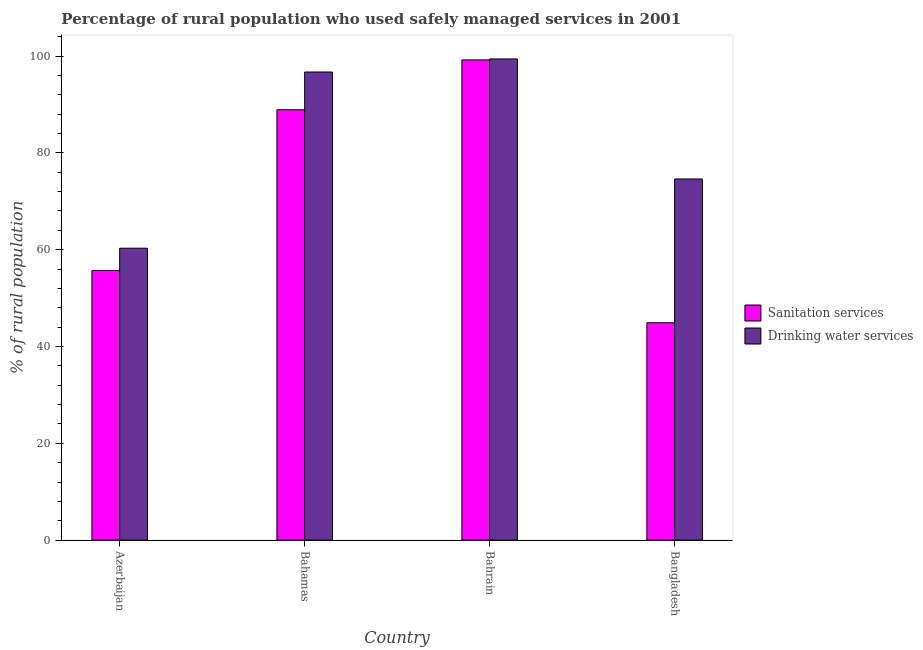How many different coloured bars are there?
Give a very brief answer. 2. How many groups of bars are there?
Provide a succinct answer. 4. How many bars are there on the 4th tick from the right?
Offer a very short reply. 2. What is the label of the 1st group of bars from the left?
Keep it short and to the point. Azerbaijan. In how many cases, is the number of bars for a given country not equal to the number of legend labels?
Keep it short and to the point. 0. What is the percentage of rural population who used drinking water services in Bahrain?
Your response must be concise. 99.4. Across all countries, what is the maximum percentage of rural population who used drinking water services?
Provide a short and direct response. 99.4. Across all countries, what is the minimum percentage of rural population who used sanitation services?
Keep it short and to the point. 44.9. In which country was the percentage of rural population who used drinking water services maximum?
Give a very brief answer. Bahrain. In which country was the percentage of rural population who used drinking water services minimum?
Ensure brevity in your answer.  Azerbaijan. What is the total percentage of rural population who used sanitation services in the graph?
Give a very brief answer. 288.7. What is the difference between the percentage of rural population who used sanitation services in Azerbaijan and that in Bahamas?
Your response must be concise. -33.2. What is the difference between the percentage of rural population who used sanitation services in Bahrain and the percentage of rural population who used drinking water services in Azerbaijan?
Provide a short and direct response. 38.9. What is the average percentage of rural population who used drinking water services per country?
Ensure brevity in your answer.  82.75. What is the difference between the percentage of rural population who used drinking water services and percentage of rural population who used sanitation services in Bahamas?
Keep it short and to the point. 7.8. What is the ratio of the percentage of rural population who used sanitation services in Bahrain to that in Bangladesh?
Make the answer very short. 2.21. Is the percentage of rural population who used drinking water services in Bahrain less than that in Bangladesh?
Offer a very short reply. No. Is the difference between the percentage of rural population who used drinking water services in Bahamas and Bangladesh greater than the difference between the percentage of rural population who used sanitation services in Bahamas and Bangladesh?
Your answer should be very brief. No. What is the difference between the highest and the second highest percentage of rural population who used sanitation services?
Provide a succinct answer. 10.3. What is the difference between the highest and the lowest percentage of rural population who used drinking water services?
Your response must be concise. 39.1. What does the 2nd bar from the left in Bahrain represents?
Give a very brief answer. Drinking water services. What does the 2nd bar from the right in Bangladesh represents?
Offer a very short reply. Sanitation services. What is the difference between two consecutive major ticks on the Y-axis?
Your response must be concise. 20. Does the graph contain grids?
Ensure brevity in your answer.  No. Where does the legend appear in the graph?
Give a very brief answer. Center right. How many legend labels are there?
Your answer should be compact. 2. How are the legend labels stacked?
Give a very brief answer. Vertical. What is the title of the graph?
Your response must be concise. Percentage of rural population who used safely managed services in 2001. What is the label or title of the Y-axis?
Ensure brevity in your answer.  % of rural population. What is the % of rural population in Sanitation services in Azerbaijan?
Offer a very short reply. 55.7. What is the % of rural population in Drinking water services in Azerbaijan?
Ensure brevity in your answer.  60.3. What is the % of rural population in Sanitation services in Bahamas?
Keep it short and to the point. 88.9. What is the % of rural population in Drinking water services in Bahamas?
Your answer should be compact. 96.7. What is the % of rural population in Sanitation services in Bahrain?
Ensure brevity in your answer.  99.2. What is the % of rural population of Drinking water services in Bahrain?
Provide a succinct answer. 99.4. What is the % of rural population of Sanitation services in Bangladesh?
Give a very brief answer. 44.9. What is the % of rural population of Drinking water services in Bangladesh?
Give a very brief answer. 74.6. Across all countries, what is the maximum % of rural population of Sanitation services?
Make the answer very short. 99.2. Across all countries, what is the maximum % of rural population of Drinking water services?
Ensure brevity in your answer.  99.4. Across all countries, what is the minimum % of rural population of Sanitation services?
Your answer should be compact. 44.9. Across all countries, what is the minimum % of rural population of Drinking water services?
Your answer should be very brief. 60.3. What is the total % of rural population of Sanitation services in the graph?
Your answer should be compact. 288.7. What is the total % of rural population of Drinking water services in the graph?
Ensure brevity in your answer.  331. What is the difference between the % of rural population of Sanitation services in Azerbaijan and that in Bahamas?
Keep it short and to the point. -33.2. What is the difference between the % of rural population of Drinking water services in Azerbaijan and that in Bahamas?
Your answer should be compact. -36.4. What is the difference between the % of rural population in Sanitation services in Azerbaijan and that in Bahrain?
Make the answer very short. -43.5. What is the difference between the % of rural population of Drinking water services in Azerbaijan and that in Bahrain?
Your answer should be very brief. -39.1. What is the difference between the % of rural population of Sanitation services in Azerbaijan and that in Bangladesh?
Provide a succinct answer. 10.8. What is the difference between the % of rural population of Drinking water services in Azerbaijan and that in Bangladesh?
Provide a short and direct response. -14.3. What is the difference between the % of rural population in Drinking water services in Bahamas and that in Bangladesh?
Give a very brief answer. 22.1. What is the difference between the % of rural population in Sanitation services in Bahrain and that in Bangladesh?
Give a very brief answer. 54.3. What is the difference between the % of rural population in Drinking water services in Bahrain and that in Bangladesh?
Your response must be concise. 24.8. What is the difference between the % of rural population in Sanitation services in Azerbaijan and the % of rural population in Drinking water services in Bahamas?
Make the answer very short. -41. What is the difference between the % of rural population in Sanitation services in Azerbaijan and the % of rural population in Drinking water services in Bahrain?
Your response must be concise. -43.7. What is the difference between the % of rural population of Sanitation services in Azerbaijan and the % of rural population of Drinking water services in Bangladesh?
Give a very brief answer. -18.9. What is the difference between the % of rural population in Sanitation services in Bahamas and the % of rural population in Drinking water services in Bangladesh?
Your answer should be very brief. 14.3. What is the difference between the % of rural population of Sanitation services in Bahrain and the % of rural population of Drinking water services in Bangladesh?
Offer a very short reply. 24.6. What is the average % of rural population in Sanitation services per country?
Ensure brevity in your answer.  72.17. What is the average % of rural population in Drinking water services per country?
Make the answer very short. 82.75. What is the difference between the % of rural population in Sanitation services and % of rural population in Drinking water services in Azerbaijan?
Keep it short and to the point. -4.6. What is the difference between the % of rural population of Sanitation services and % of rural population of Drinking water services in Bahamas?
Ensure brevity in your answer.  -7.8. What is the difference between the % of rural population of Sanitation services and % of rural population of Drinking water services in Bahrain?
Provide a succinct answer. -0.2. What is the difference between the % of rural population of Sanitation services and % of rural population of Drinking water services in Bangladesh?
Provide a succinct answer. -29.7. What is the ratio of the % of rural population in Sanitation services in Azerbaijan to that in Bahamas?
Your response must be concise. 0.63. What is the ratio of the % of rural population in Drinking water services in Azerbaijan to that in Bahamas?
Make the answer very short. 0.62. What is the ratio of the % of rural population in Sanitation services in Azerbaijan to that in Bahrain?
Your answer should be very brief. 0.56. What is the ratio of the % of rural population in Drinking water services in Azerbaijan to that in Bahrain?
Give a very brief answer. 0.61. What is the ratio of the % of rural population of Sanitation services in Azerbaijan to that in Bangladesh?
Keep it short and to the point. 1.24. What is the ratio of the % of rural population in Drinking water services in Azerbaijan to that in Bangladesh?
Your response must be concise. 0.81. What is the ratio of the % of rural population of Sanitation services in Bahamas to that in Bahrain?
Your response must be concise. 0.9. What is the ratio of the % of rural population in Drinking water services in Bahamas to that in Bahrain?
Provide a short and direct response. 0.97. What is the ratio of the % of rural population in Sanitation services in Bahamas to that in Bangladesh?
Your answer should be very brief. 1.98. What is the ratio of the % of rural population in Drinking water services in Bahamas to that in Bangladesh?
Your answer should be very brief. 1.3. What is the ratio of the % of rural population of Sanitation services in Bahrain to that in Bangladesh?
Your response must be concise. 2.21. What is the ratio of the % of rural population in Drinking water services in Bahrain to that in Bangladesh?
Give a very brief answer. 1.33. What is the difference between the highest and the second highest % of rural population in Sanitation services?
Ensure brevity in your answer.  10.3. What is the difference between the highest and the second highest % of rural population of Drinking water services?
Give a very brief answer. 2.7. What is the difference between the highest and the lowest % of rural population in Sanitation services?
Make the answer very short. 54.3. What is the difference between the highest and the lowest % of rural population in Drinking water services?
Offer a terse response. 39.1. 